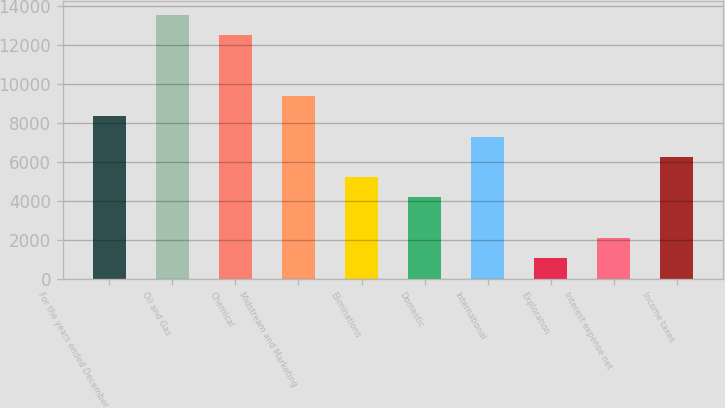<chart> <loc_0><loc_0><loc_500><loc_500><bar_chart><fcel>For the years ended December<fcel>Oil and Gas<fcel>Chemical<fcel>Midstream and Marketing<fcel>Eliminations<fcel>Domestic<fcel>International<fcel>Exploration<fcel>Interest expense net<fcel>Income taxes<nl><fcel>8353.88<fcel>13571.7<fcel>12528.1<fcel>9397.44<fcel>5223.2<fcel>4179.64<fcel>7310.32<fcel>1048.96<fcel>2092.52<fcel>6266.76<nl></chart> 